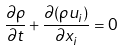<formula> <loc_0><loc_0><loc_500><loc_500>\frac { \partial \rho } { \partial t } + \frac { \partial ( \rho u _ { i } ) } { \partial x _ { i } } = 0</formula> 